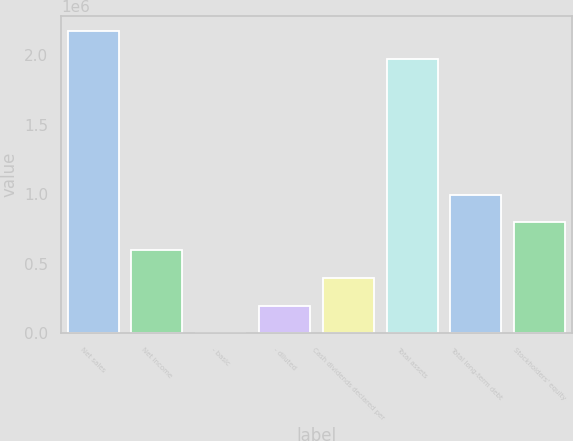Convert chart to OTSL. <chart><loc_0><loc_0><loc_500><loc_500><bar_chart><fcel>Net sales<fcel>Net income<fcel>- basic<fcel>- diluted<fcel>Cash dividends declared per<fcel>Total assets<fcel>Total long-term debt<fcel>Stockholders' equity<nl><fcel>2.17266e+06<fcel>598098<fcel>0.49<fcel>199366<fcel>398732<fcel>1.9733e+06<fcel>996829<fcel>797463<nl></chart> 